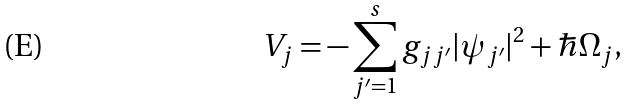Convert formula to latex. <formula><loc_0><loc_0><loc_500><loc_500>V _ { j } = - \sum _ { j ^ { \prime } = 1 } ^ { s } g _ { j j ^ { \prime } } | \psi _ { j ^ { \prime } } | ^ { 2 } + \hbar { \Omega } _ { j } ,</formula> 